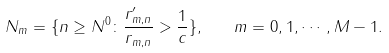<formula> <loc_0><loc_0><loc_500><loc_500>N _ { m } = \{ n \geq N ^ { 0 } \colon \frac { r ^ { \prime } _ { m , n } } { r _ { m , n } } > \frac { 1 } { c } \} , \quad m = 0 , 1 , \cdots , M - 1 .</formula> 